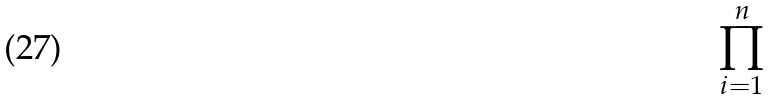<formula> <loc_0><loc_0><loc_500><loc_500>\prod _ { i = 1 } ^ { n }</formula> 